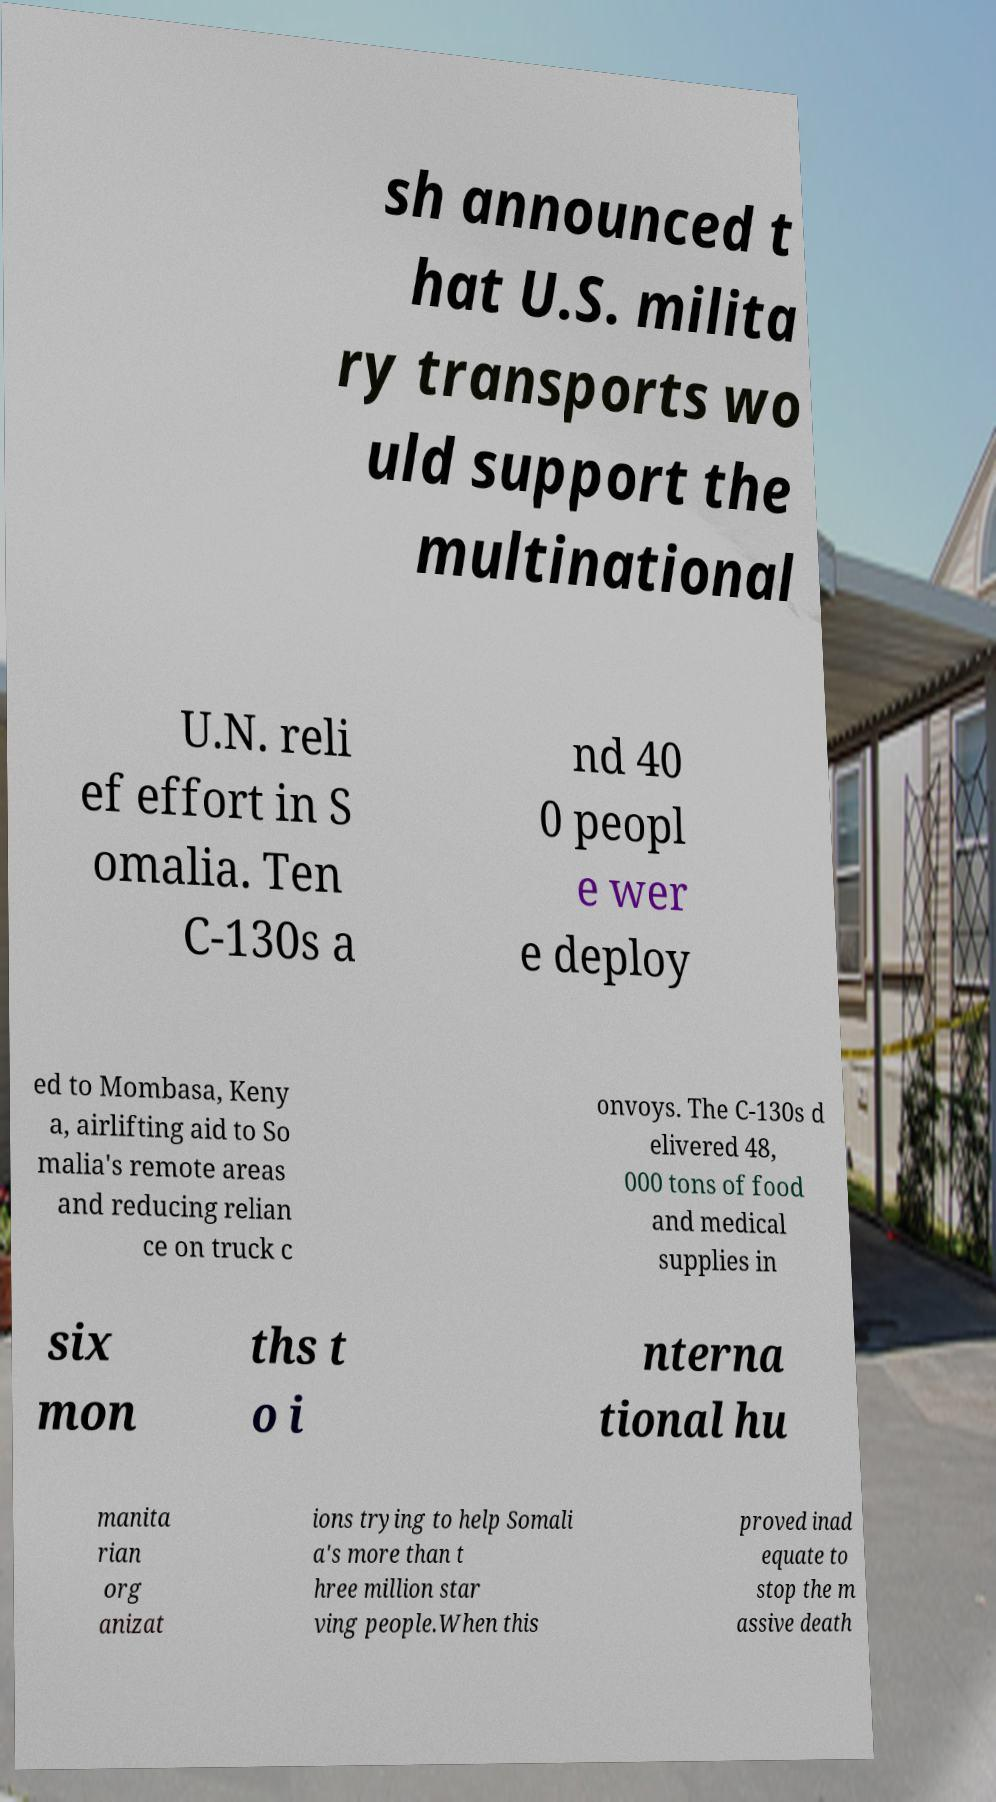Please identify and transcribe the text found in this image. sh announced t hat U.S. milita ry transports wo uld support the multinational U.N. reli ef effort in S omalia. Ten C-130s a nd 40 0 peopl e wer e deploy ed to Mombasa, Keny a, airlifting aid to So malia's remote areas and reducing relian ce on truck c onvoys. The C-130s d elivered 48, 000 tons of food and medical supplies in six mon ths t o i nterna tional hu manita rian org anizat ions trying to help Somali a's more than t hree million star ving people.When this proved inad equate to stop the m assive death 